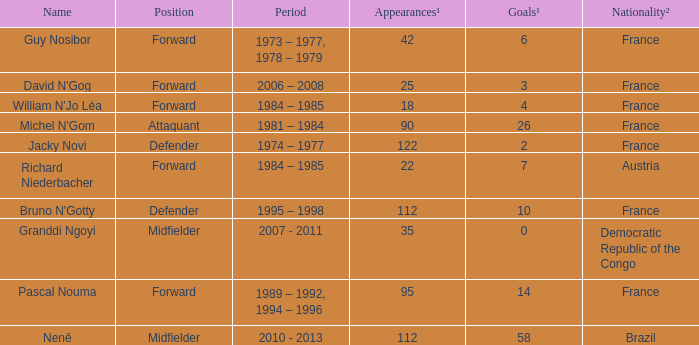List the number of active years for attaquant. 1981 – 1984. 